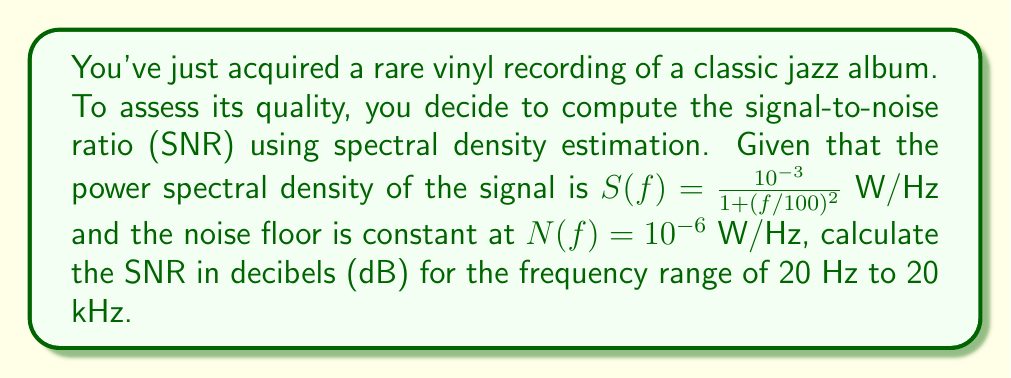Could you help me with this problem? To compute the SNR using spectral density estimation, we follow these steps:

1) The signal-to-noise ratio is defined as the ratio of signal power to noise power:

   $$ SNR = \frac{P_{signal}}{P_{noise}} $$

2) To find the power, we integrate the power spectral density over the frequency range:

   $$ P = \int_{f_1}^{f_2} S(f) df $$

3) For the signal:
   
   $$ P_{signal} = \int_{20}^{20000} \frac{10^{-3}}{1 + (f/100)^2} df $$

4) This integral can be solved analytically:

   $$ P_{signal} = 10^{-3} \cdot 100 \cdot [\arctan(f/100)]_{20}^{20000} $$
   $$ = 0.1 \cdot [\arctan(200) - \arctan(0.2)] $$
   $$ \approx 0.1 \cdot [1.5608 - 0.1974] = 0.1363 \text{ W} $$

5) For the noise:

   $$ P_{noise} = \int_{20}^{20000} 10^{-6} df = 10^{-6} \cdot (20000 - 20) = 0.01998 \text{ W} $$

6) The SNR is:

   $$ SNR = \frac{0.1363}{0.01998} = 6.8218 $$

7) Convert to decibels:

   $$ SNR_{dB} = 10 \log_{10}(SNR) = 10 \log_{10}(6.8218) \approx 8.34 \text{ dB} $$
Answer: 8.34 dB 